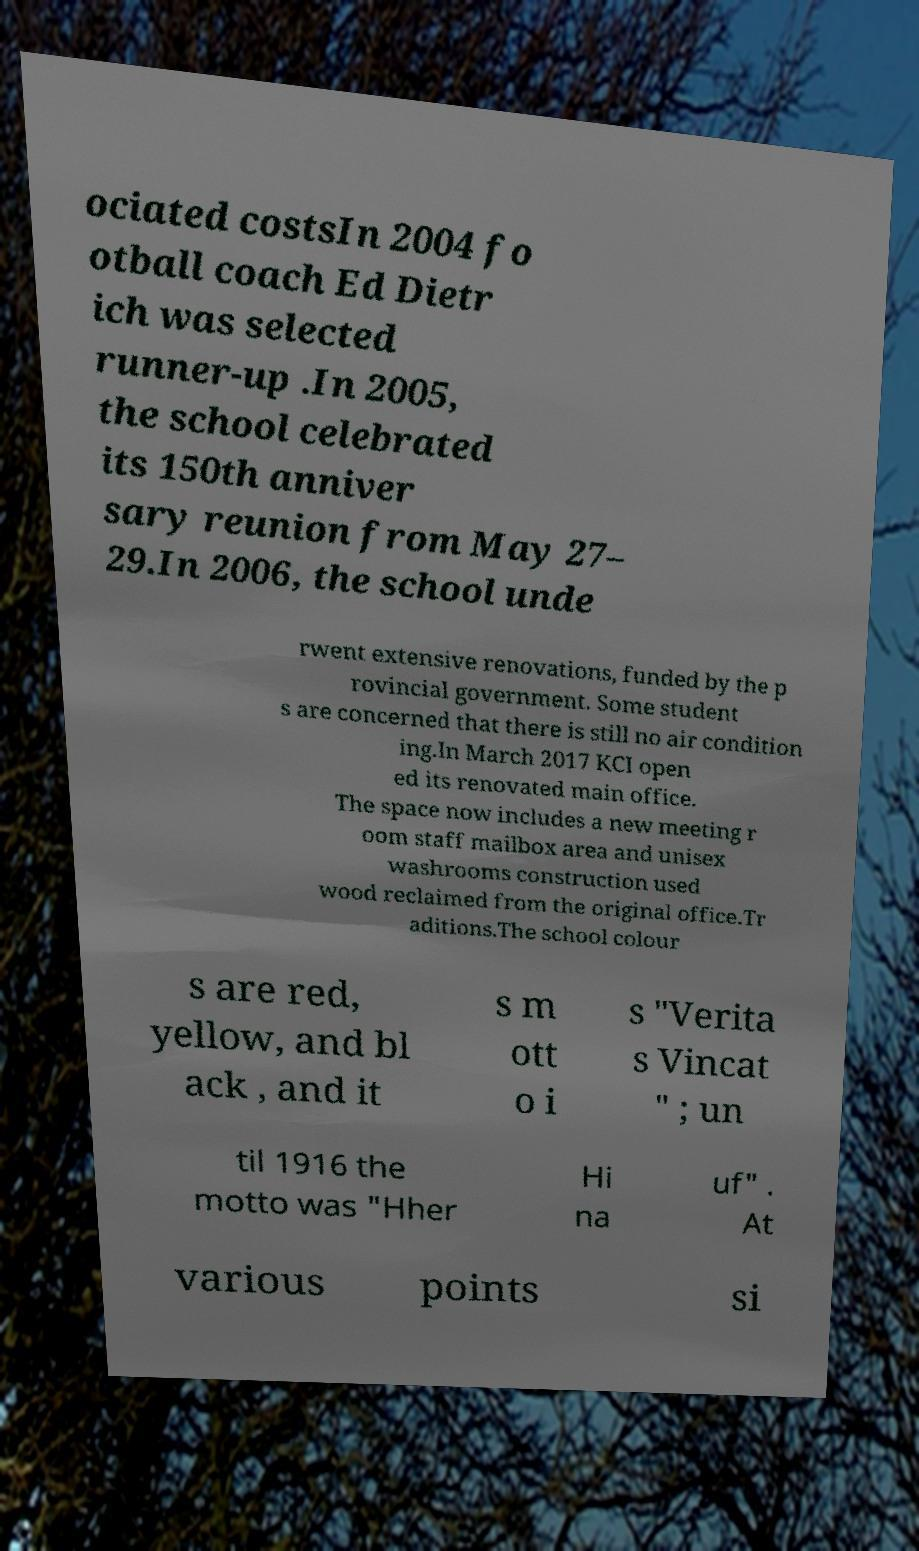What messages or text are displayed in this image? I need them in a readable, typed format. ociated costsIn 2004 fo otball coach Ed Dietr ich was selected runner-up .In 2005, the school celebrated its 150th anniver sary reunion from May 27– 29.In 2006, the school unde rwent extensive renovations, funded by the p rovincial government. Some student s are concerned that there is still no air condition ing.In March 2017 KCI open ed its renovated main office. The space now includes a new meeting r oom staff mailbox area and unisex washrooms construction used wood reclaimed from the original office.Tr aditions.The school colour s are red, yellow, and bl ack , and it s m ott o i s "Verita s Vincat " ; un til 1916 the motto was "Hher Hi na uf" . At various points si 